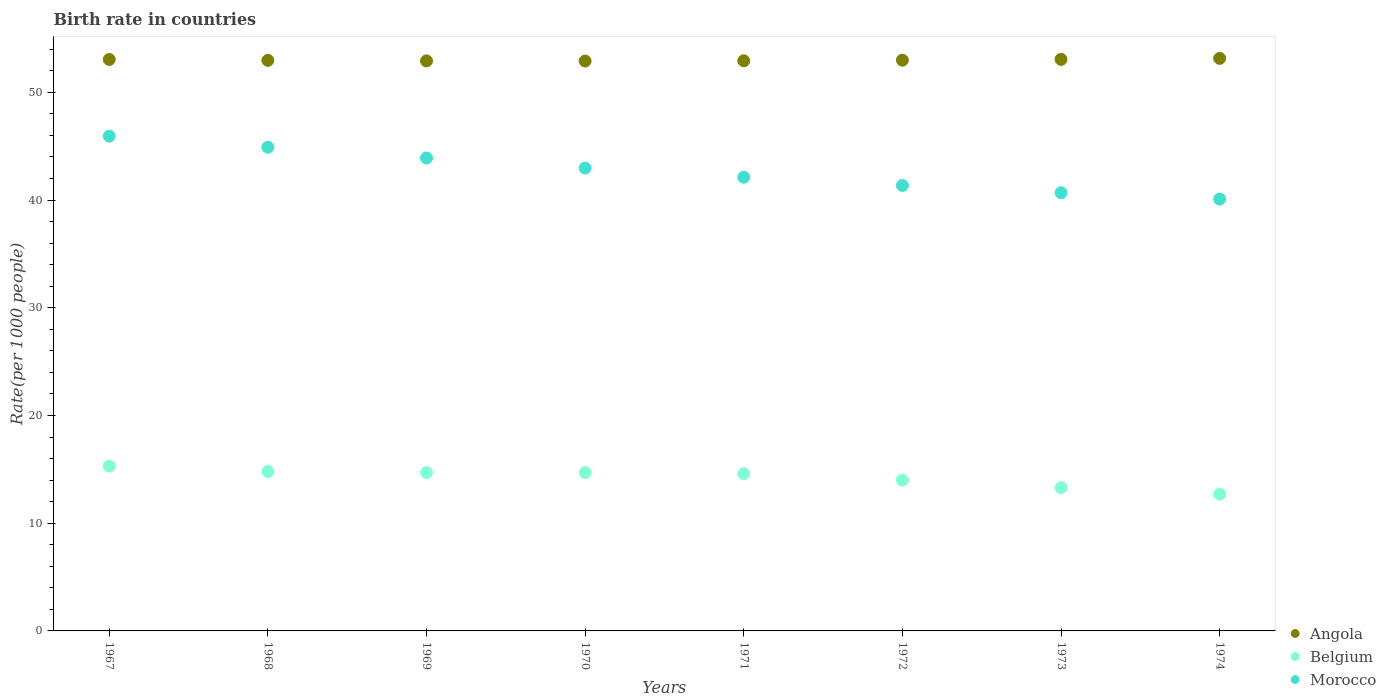How many different coloured dotlines are there?
Your answer should be very brief. 3. Is the number of dotlines equal to the number of legend labels?
Your answer should be very brief. Yes. What is the birth rate in Morocco in 1968?
Your response must be concise. 44.9. In which year was the birth rate in Morocco maximum?
Your response must be concise. 1967. In which year was the birth rate in Belgium minimum?
Give a very brief answer. 1974. What is the total birth rate in Belgium in the graph?
Offer a terse response. 114.1. What is the difference between the birth rate in Angola in 1967 and that in 1972?
Provide a short and direct response. 0.07. What is the difference between the birth rate in Belgium in 1969 and the birth rate in Morocco in 1972?
Your response must be concise. -26.66. What is the average birth rate in Morocco per year?
Keep it short and to the point. 42.74. In the year 1972, what is the difference between the birth rate in Belgium and birth rate in Angola?
Keep it short and to the point. -38.98. In how many years, is the birth rate in Belgium greater than 52?
Offer a terse response. 0. What is the ratio of the birth rate in Belgium in 1968 to that in 1972?
Your answer should be very brief. 1.06. Is the birth rate in Morocco in 1969 less than that in 1973?
Provide a succinct answer. No. Is the difference between the birth rate in Belgium in 1970 and 1971 greater than the difference between the birth rate in Angola in 1970 and 1971?
Give a very brief answer. Yes. What is the difference between the highest and the lowest birth rate in Angola?
Keep it short and to the point. 0.25. Is it the case that in every year, the sum of the birth rate in Belgium and birth rate in Angola  is greater than the birth rate in Morocco?
Keep it short and to the point. Yes. Does the birth rate in Morocco monotonically increase over the years?
Provide a short and direct response. No. Is the birth rate in Morocco strictly less than the birth rate in Belgium over the years?
Your response must be concise. No. How many years are there in the graph?
Ensure brevity in your answer.  8. What is the difference between two consecutive major ticks on the Y-axis?
Offer a terse response. 10. Does the graph contain any zero values?
Your response must be concise. No. How many legend labels are there?
Your answer should be very brief. 3. What is the title of the graph?
Give a very brief answer. Birth rate in countries. What is the label or title of the Y-axis?
Keep it short and to the point. Rate(per 1000 people). What is the Rate(per 1000 people) in Angola in 1967?
Make the answer very short. 53.05. What is the Rate(per 1000 people) of Belgium in 1967?
Your answer should be very brief. 15.3. What is the Rate(per 1000 people) of Morocco in 1967?
Keep it short and to the point. 45.93. What is the Rate(per 1000 people) in Angola in 1968?
Give a very brief answer. 52.97. What is the Rate(per 1000 people) of Belgium in 1968?
Your response must be concise. 14.8. What is the Rate(per 1000 people) in Morocco in 1968?
Ensure brevity in your answer.  44.9. What is the Rate(per 1000 people) in Angola in 1969?
Ensure brevity in your answer.  52.92. What is the Rate(per 1000 people) of Belgium in 1969?
Offer a terse response. 14.7. What is the Rate(per 1000 people) of Morocco in 1969?
Your response must be concise. 43.91. What is the Rate(per 1000 people) of Angola in 1970?
Give a very brief answer. 52.91. What is the Rate(per 1000 people) in Belgium in 1970?
Make the answer very short. 14.7. What is the Rate(per 1000 people) in Morocco in 1970?
Your response must be concise. 42.97. What is the Rate(per 1000 people) in Angola in 1971?
Provide a succinct answer. 52.93. What is the Rate(per 1000 people) of Belgium in 1971?
Give a very brief answer. 14.6. What is the Rate(per 1000 people) in Morocco in 1971?
Make the answer very short. 42.12. What is the Rate(per 1000 people) in Angola in 1972?
Provide a succinct answer. 52.98. What is the Rate(per 1000 people) in Belgium in 1972?
Provide a succinct answer. 14. What is the Rate(per 1000 people) of Morocco in 1972?
Offer a terse response. 41.36. What is the Rate(per 1000 people) of Angola in 1973?
Offer a very short reply. 53.06. What is the Rate(per 1000 people) in Morocco in 1973?
Your response must be concise. 40.68. What is the Rate(per 1000 people) in Angola in 1974?
Your response must be concise. 53.15. What is the Rate(per 1000 people) in Belgium in 1974?
Provide a succinct answer. 12.7. What is the Rate(per 1000 people) in Morocco in 1974?
Give a very brief answer. 40.09. Across all years, what is the maximum Rate(per 1000 people) in Angola?
Provide a succinct answer. 53.15. Across all years, what is the maximum Rate(per 1000 people) in Belgium?
Your answer should be very brief. 15.3. Across all years, what is the maximum Rate(per 1000 people) of Morocco?
Keep it short and to the point. 45.93. Across all years, what is the minimum Rate(per 1000 people) in Angola?
Provide a succinct answer. 52.91. Across all years, what is the minimum Rate(per 1000 people) in Morocco?
Your answer should be very brief. 40.09. What is the total Rate(per 1000 people) in Angola in the graph?
Provide a short and direct response. 423.97. What is the total Rate(per 1000 people) of Belgium in the graph?
Your answer should be compact. 114.1. What is the total Rate(per 1000 people) of Morocco in the graph?
Your answer should be very brief. 341.94. What is the difference between the Rate(per 1000 people) in Angola in 1967 and that in 1968?
Provide a short and direct response. 0.08. What is the difference between the Rate(per 1000 people) of Belgium in 1967 and that in 1968?
Offer a terse response. 0.5. What is the difference between the Rate(per 1000 people) of Angola in 1967 and that in 1969?
Keep it short and to the point. 0.13. What is the difference between the Rate(per 1000 people) in Belgium in 1967 and that in 1969?
Offer a terse response. 0.6. What is the difference between the Rate(per 1000 people) in Morocco in 1967 and that in 1969?
Make the answer very short. 2.02. What is the difference between the Rate(per 1000 people) in Angola in 1967 and that in 1970?
Keep it short and to the point. 0.15. What is the difference between the Rate(per 1000 people) of Belgium in 1967 and that in 1970?
Offer a terse response. 0.6. What is the difference between the Rate(per 1000 people) in Morocco in 1967 and that in 1970?
Provide a short and direct response. 2.96. What is the difference between the Rate(per 1000 people) of Angola in 1967 and that in 1971?
Give a very brief answer. 0.12. What is the difference between the Rate(per 1000 people) in Morocco in 1967 and that in 1971?
Make the answer very short. 3.81. What is the difference between the Rate(per 1000 people) in Angola in 1967 and that in 1972?
Your answer should be very brief. 0.07. What is the difference between the Rate(per 1000 people) of Belgium in 1967 and that in 1972?
Offer a terse response. 1.3. What is the difference between the Rate(per 1000 people) in Morocco in 1967 and that in 1972?
Keep it short and to the point. 4.57. What is the difference between the Rate(per 1000 people) of Angola in 1967 and that in 1973?
Give a very brief answer. -0.01. What is the difference between the Rate(per 1000 people) in Morocco in 1967 and that in 1973?
Make the answer very short. 5.25. What is the difference between the Rate(per 1000 people) of Angola in 1967 and that in 1974?
Your answer should be very brief. -0.1. What is the difference between the Rate(per 1000 people) of Belgium in 1967 and that in 1974?
Ensure brevity in your answer.  2.6. What is the difference between the Rate(per 1000 people) of Morocco in 1967 and that in 1974?
Keep it short and to the point. 5.84. What is the difference between the Rate(per 1000 people) in Angola in 1968 and that in 1969?
Offer a very short reply. 0.05. What is the difference between the Rate(per 1000 people) of Angola in 1968 and that in 1970?
Your answer should be very brief. 0.06. What is the difference between the Rate(per 1000 people) of Morocco in 1968 and that in 1970?
Your answer should be very brief. 1.93. What is the difference between the Rate(per 1000 people) of Morocco in 1968 and that in 1971?
Provide a short and direct response. 2.78. What is the difference between the Rate(per 1000 people) in Angola in 1968 and that in 1972?
Your response must be concise. -0.01. What is the difference between the Rate(per 1000 people) of Belgium in 1968 and that in 1972?
Your response must be concise. 0.8. What is the difference between the Rate(per 1000 people) of Morocco in 1968 and that in 1972?
Your answer should be very brief. 3.55. What is the difference between the Rate(per 1000 people) in Angola in 1968 and that in 1973?
Your answer should be compact. -0.09. What is the difference between the Rate(per 1000 people) in Belgium in 1968 and that in 1973?
Offer a very short reply. 1.5. What is the difference between the Rate(per 1000 people) in Morocco in 1968 and that in 1973?
Give a very brief answer. 4.22. What is the difference between the Rate(per 1000 people) of Angola in 1968 and that in 1974?
Your answer should be compact. -0.18. What is the difference between the Rate(per 1000 people) of Belgium in 1968 and that in 1974?
Offer a terse response. 2.1. What is the difference between the Rate(per 1000 people) of Morocco in 1968 and that in 1974?
Offer a very short reply. 4.81. What is the difference between the Rate(per 1000 people) in Angola in 1969 and that in 1970?
Provide a succinct answer. 0.01. What is the difference between the Rate(per 1000 people) of Belgium in 1969 and that in 1970?
Ensure brevity in your answer.  0. What is the difference between the Rate(per 1000 people) of Morocco in 1969 and that in 1970?
Make the answer very short. 0.94. What is the difference between the Rate(per 1000 people) of Angola in 1969 and that in 1971?
Ensure brevity in your answer.  -0.01. What is the difference between the Rate(per 1000 people) of Morocco in 1969 and that in 1971?
Keep it short and to the point. 1.79. What is the difference between the Rate(per 1000 people) of Angola in 1969 and that in 1972?
Provide a short and direct response. -0.06. What is the difference between the Rate(per 1000 people) in Morocco in 1969 and that in 1972?
Your answer should be compact. 2.55. What is the difference between the Rate(per 1000 people) in Angola in 1969 and that in 1973?
Your answer should be very brief. -0.14. What is the difference between the Rate(per 1000 people) of Morocco in 1969 and that in 1973?
Your response must be concise. 3.23. What is the difference between the Rate(per 1000 people) of Angola in 1969 and that in 1974?
Give a very brief answer. -0.23. What is the difference between the Rate(per 1000 people) of Belgium in 1969 and that in 1974?
Your answer should be compact. 2. What is the difference between the Rate(per 1000 people) of Morocco in 1969 and that in 1974?
Your answer should be compact. 3.82. What is the difference between the Rate(per 1000 people) in Angola in 1970 and that in 1971?
Ensure brevity in your answer.  -0.02. What is the difference between the Rate(per 1000 people) in Belgium in 1970 and that in 1971?
Your response must be concise. 0.1. What is the difference between the Rate(per 1000 people) in Angola in 1970 and that in 1972?
Provide a short and direct response. -0.08. What is the difference between the Rate(per 1000 people) in Belgium in 1970 and that in 1972?
Offer a terse response. 0.7. What is the difference between the Rate(per 1000 people) of Morocco in 1970 and that in 1972?
Your response must be concise. 1.61. What is the difference between the Rate(per 1000 people) of Angola in 1970 and that in 1973?
Your answer should be very brief. -0.16. What is the difference between the Rate(per 1000 people) of Belgium in 1970 and that in 1973?
Ensure brevity in your answer.  1.4. What is the difference between the Rate(per 1000 people) in Morocco in 1970 and that in 1973?
Your answer should be very brief. 2.29. What is the difference between the Rate(per 1000 people) of Angola in 1970 and that in 1974?
Provide a succinct answer. -0.25. What is the difference between the Rate(per 1000 people) in Belgium in 1970 and that in 1974?
Provide a succinct answer. 2. What is the difference between the Rate(per 1000 people) in Morocco in 1970 and that in 1974?
Provide a short and direct response. 2.88. What is the difference between the Rate(per 1000 people) of Angola in 1971 and that in 1972?
Your response must be concise. -0.06. What is the difference between the Rate(per 1000 people) of Morocco in 1971 and that in 1972?
Your response must be concise. 0.76. What is the difference between the Rate(per 1000 people) in Angola in 1971 and that in 1973?
Provide a short and direct response. -0.13. What is the difference between the Rate(per 1000 people) in Belgium in 1971 and that in 1973?
Provide a short and direct response. 1.3. What is the difference between the Rate(per 1000 people) in Morocco in 1971 and that in 1973?
Provide a succinct answer. 1.44. What is the difference between the Rate(per 1000 people) of Angola in 1971 and that in 1974?
Offer a very short reply. -0.23. What is the difference between the Rate(per 1000 people) in Belgium in 1971 and that in 1974?
Your answer should be compact. 1.9. What is the difference between the Rate(per 1000 people) of Morocco in 1971 and that in 1974?
Provide a succinct answer. 2.03. What is the difference between the Rate(per 1000 people) in Angola in 1972 and that in 1973?
Keep it short and to the point. -0.08. What is the difference between the Rate(per 1000 people) in Morocco in 1972 and that in 1973?
Offer a terse response. 0.68. What is the difference between the Rate(per 1000 people) in Angola in 1972 and that in 1974?
Make the answer very short. -0.17. What is the difference between the Rate(per 1000 people) in Morocco in 1972 and that in 1974?
Your response must be concise. 1.27. What is the difference between the Rate(per 1000 people) in Angola in 1973 and that in 1974?
Your answer should be very brief. -0.09. What is the difference between the Rate(per 1000 people) of Morocco in 1973 and that in 1974?
Offer a terse response. 0.59. What is the difference between the Rate(per 1000 people) in Angola in 1967 and the Rate(per 1000 people) in Belgium in 1968?
Provide a short and direct response. 38.25. What is the difference between the Rate(per 1000 people) of Angola in 1967 and the Rate(per 1000 people) of Morocco in 1968?
Your answer should be very brief. 8.15. What is the difference between the Rate(per 1000 people) of Belgium in 1967 and the Rate(per 1000 people) of Morocco in 1968?
Ensure brevity in your answer.  -29.6. What is the difference between the Rate(per 1000 people) of Angola in 1967 and the Rate(per 1000 people) of Belgium in 1969?
Your response must be concise. 38.35. What is the difference between the Rate(per 1000 people) in Angola in 1967 and the Rate(per 1000 people) in Morocco in 1969?
Give a very brief answer. 9.15. What is the difference between the Rate(per 1000 people) of Belgium in 1967 and the Rate(per 1000 people) of Morocco in 1969?
Your response must be concise. -28.61. What is the difference between the Rate(per 1000 people) of Angola in 1967 and the Rate(per 1000 people) of Belgium in 1970?
Your answer should be compact. 38.35. What is the difference between the Rate(per 1000 people) of Angola in 1967 and the Rate(per 1000 people) of Morocco in 1970?
Your response must be concise. 10.08. What is the difference between the Rate(per 1000 people) in Belgium in 1967 and the Rate(per 1000 people) in Morocco in 1970?
Your response must be concise. -27.67. What is the difference between the Rate(per 1000 people) in Angola in 1967 and the Rate(per 1000 people) in Belgium in 1971?
Provide a short and direct response. 38.45. What is the difference between the Rate(per 1000 people) of Angola in 1967 and the Rate(per 1000 people) of Morocco in 1971?
Your answer should be very brief. 10.93. What is the difference between the Rate(per 1000 people) of Belgium in 1967 and the Rate(per 1000 people) of Morocco in 1971?
Ensure brevity in your answer.  -26.82. What is the difference between the Rate(per 1000 people) of Angola in 1967 and the Rate(per 1000 people) of Belgium in 1972?
Make the answer very short. 39.05. What is the difference between the Rate(per 1000 people) in Angola in 1967 and the Rate(per 1000 people) in Morocco in 1972?
Keep it short and to the point. 11.7. What is the difference between the Rate(per 1000 people) of Belgium in 1967 and the Rate(per 1000 people) of Morocco in 1972?
Your answer should be very brief. -26.06. What is the difference between the Rate(per 1000 people) of Angola in 1967 and the Rate(per 1000 people) of Belgium in 1973?
Your answer should be very brief. 39.75. What is the difference between the Rate(per 1000 people) of Angola in 1967 and the Rate(per 1000 people) of Morocco in 1973?
Make the answer very short. 12.37. What is the difference between the Rate(per 1000 people) of Belgium in 1967 and the Rate(per 1000 people) of Morocco in 1973?
Provide a short and direct response. -25.38. What is the difference between the Rate(per 1000 people) of Angola in 1967 and the Rate(per 1000 people) of Belgium in 1974?
Offer a terse response. 40.35. What is the difference between the Rate(per 1000 people) of Angola in 1967 and the Rate(per 1000 people) of Morocco in 1974?
Make the answer very short. 12.96. What is the difference between the Rate(per 1000 people) of Belgium in 1967 and the Rate(per 1000 people) of Morocco in 1974?
Offer a terse response. -24.79. What is the difference between the Rate(per 1000 people) in Angola in 1968 and the Rate(per 1000 people) in Belgium in 1969?
Your response must be concise. 38.27. What is the difference between the Rate(per 1000 people) of Angola in 1968 and the Rate(per 1000 people) of Morocco in 1969?
Provide a succinct answer. 9.06. What is the difference between the Rate(per 1000 people) of Belgium in 1968 and the Rate(per 1000 people) of Morocco in 1969?
Your answer should be compact. -29.11. What is the difference between the Rate(per 1000 people) in Angola in 1968 and the Rate(per 1000 people) in Belgium in 1970?
Offer a terse response. 38.27. What is the difference between the Rate(per 1000 people) of Angola in 1968 and the Rate(per 1000 people) of Morocco in 1970?
Offer a very short reply. 10. What is the difference between the Rate(per 1000 people) of Belgium in 1968 and the Rate(per 1000 people) of Morocco in 1970?
Ensure brevity in your answer.  -28.17. What is the difference between the Rate(per 1000 people) of Angola in 1968 and the Rate(per 1000 people) of Belgium in 1971?
Ensure brevity in your answer.  38.37. What is the difference between the Rate(per 1000 people) in Angola in 1968 and the Rate(per 1000 people) in Morocco in 1971?
Provide a short and direct response. 10.85. What is the difference between the Rate(per 1000 people) of Belgium in 1968 and the Rate(per 1000 people) of Morocco in 1971?
Keep it short and to the point. -27.32. What is the difference between the Rate(per 1000 people) in Angola in 1968 and the Rate(per 1000 people) in Belgium in 1972?
Your answer should be compact. 38.97. What is the difference between the Rate(per 1000 people) of Angola in 1968 and the Rate(per 1000 people) of Morocco in 1972?
Provide a succinct answer. 11.61. What is the difference between the Rate(per 1000 people) of Belgium in 1968 and the Rate(per 1000 people) of Morocco in 1972?
Make the answer very short. -26.56. What is the difference between the Rate(per 1000 people) of Angola in 1968 and the Rate(per 1000 people) of Belgium in 1973?
Offer a very short reply. 39.67. What is the difference between the Rate(per 1000 people) of Angola in 1968 and the Rate(per 1000 people) of Morocco in 1973?
Your answer should be compact. 12.29. What is the difference between the Rate(per 1000 people) in Belgium in 1968 and the Rate(per 1000 people) in Morocco in 1973?
Offer a terse response. -25.88. What is the difference between the Rate(per 1000 people) in Angola in 1968 and the Rate(per 1000 people) in Belgium in 1974?
Make the answer very short. 40.27. What is the difference between the Rate(per 1000 people) in Angola in 1968 and the Rate(per 1000 people) in Morocco in 1974?
Your answer should be very brief. 12.88. What is the difference between the Rate(per 1000 people) in Belgium in 1968 and the Rate(per 1000 people) in Morocco in 1974?
Offer a very short reply. -25.29. What is the difference between the Rate(per 1000 people) of Angola in 1969 and the Rate(per 1000 people) of Belgium in 1970?
Offer a terse response. 38.22. What is the difference between the Rate(per 1000 people) of Angola in 1969 and the Rate(per 1000 people) of Morocco in 1970?
Provide a succinct answer. 9.95. What is the difference between the Rate(per 1000 people) in Belgium in 1969 and the Rate(per 1000 people) in Morocco in 1970?
Keep it short and to the point. -28.27. What is the difference between the Rate(per 1000 people) in Angola in 1969 and the Rate(per 1000 people) in Belgium in 1971?
Provide a short and direct response. 38.32. What is the difference between the Rate(per 1000 people) in Angola in 1969 and the Rate(per 1000 people) in Morocco in 1971?
Provide a short and direct response. 10.8. What is the difference between the Rate(per 1000 people) in Belgium in 1969 and the Rate(per 1000 people) in Morocco in 1971?
Ensure brevity in your answer.  -27.42. What is the difference between the Rate(per 1000 people) in Angola in 1969 and the Rate(per 1000 people) in Belgium in 1972?
Offer a terse response. 38.92. What is the difference between the Rate(per 1000 people) in Angola in 1969 and the Rate(per 1000 people) in Morocco in 1972?
Offer a very short reply. 11.56. What is the difference between the Rate(per 1000 people) of Belgium in 1969 and the Rate(per 1000 people) of Morocco in 1972?
Ensure brevity in your answer.  -26.66. What is the difference between the Rate(per 1000 people) in Angola in 1969 and the Rate(per 1000 people) in Belgium in 1973?
Keep it short and to the point. 39.62. What is the difference between the Rate(per 1000 people) of Angola in 1969 and the Rate(per 1000 people) of Morocco in 1973?
Your answer should be very brief. 12.24. What is the difference between the Rate(per 1000 people) of Belgium in 1969 and the Rate(per 1000 people) of Morocco in 1973?
Make the answer very short. -25.98. What is the difference between the Rate(per 1000 people) of Angola in 1969 and the Rate(per 1000 people) of Belgium in 1974?
Your answer should be very brief. 40.22. What is the difference between the Rate(per 1000 people) in Angola in 1969 and the Rate(per 1000 people) in Morocco in 1974?
Your answer should be very brief. 12.83. What is the difference between the Rate(per 1000 people) of Belgium in 1969 and the Rate(per 1000 people) of Morocco in 1974?
Make the answer very short. -25.39. What is the difference between the Rate(per 1000 people) of Angola in 1970 and the Rate(per 1000 people) of Belgium in 1971?
Make the answer very short. 38.3. What is the difference between the Rate(per 1000 people) of Angola in 1970 and the Rate(per 1000 people) of Morocco in 1971?
Make the answer very short. 10.79. What is the difference between the Rate(per 1000 people) of Belgium in 1970 and the Rate(per 1000 people) of Morocco in 1971?
Provide a succinct answer. -27.42. What is the difference between the Rate(per 1000 people) in Angola in 1970 and the Rate(per 1000 people) in Belgium in 1972?
Make the answer very short. 38.91. What is the difference between the Rate(per 1000 people) in Angola in 1970 and the Rate(per 1000 people) in Morocco in 1972?
Offer a terse response. 11.55. What is the difference between the Rate(per 1000 people) of Belgium in 1970 and the Rate(per 1000 people) of Morocco in 1972?
Keep it short and to the point. -26.66. What is the difference between the Rate(per 1000 people) in Angola in 1970 and the Rate(per 1000 people) in Belgium in 1973?
Your answer should be very brief. 39.6. What is the difference between the Rate(per 1000 people) of Angola in 1970 and the Rate(per 1000 people) of Morocco in 1973?
Your response must be concise. 12.23. What is the difference between the Rate(per 1000 people) of Belgium in 1970 and the Rate(per 1000 people) of Morocco in 1973?
Offer a very short reply. -25.98. What is the difference between the Rate(per 1000 people) in Angola in 1970 and the Rate(per 1000 people) in Belgium in 1974?
Keep it short and to the point. 40.2. What is the difference between the Rate(per 1000 people) of Angola in 1970 and the Rate(per 1000 people) of Morocco in 1974?
Your answer should be compact. 12.82. What is the difference between the Rate(per 1000 people) of Belgium in 1970 and the Rate(per 1000 people) of Morocco in 1974?
Make the answer very short. -25.39. What is the difference between the Rate(per 1000 people) of Angola in 1971 and the Rate(per 1000 people) of Belgium in 1972?
Give a very brief answer. 38.93. What is the difference between the Rate(per 1000 people) of Angola in 1971 and the Rate(per 1000 people) of Morocco in 1972?
Offer a very short reply. 11.57. What is the difference between the Rate(per 1000 people) of Belgium in 1971 and the Rate(per 1000 people) of Morocco in 1972?
Provide a succinct answer. -26.76. What is the difference between the Rate(per 1000 people) in Angola in 1971 and the Rate(per 1000 people) in Belgium in 1973?
Your answer should be very brief. 39.63. What is the difference between the Rate(per 1000 people) of Angola in 1971 and the Rate(per 1000 people) of Morocco in 1973?
Keep it short and to the point. 12.25. What is the difference between the Rate(per 1000 people) in Belgium in 1971 and the Rate(per 1000 people) in Morocco in 1973?
Offer a very short reply. -26.08. What is the difference between the Rate(per 1000 people) of Angola in 1971 and the Rate(per 1000 people) of Belgium in 1974?
Ensure brevity in your answer.  40.23. What is the difference between the Rate(per 1000 people) in Angola in 1971 and the Rate(per 1000 people) in Morocco in 1974?
Keep it short and to the point. 12.84. What is the difference between the Rate(per 1000 people) in Belgium in 1971 and the Rate(per 1000 people) in Morocco in 1974?
Provide a short and direct response. -25.49. What is the difference between the Rate(per 1000 people) in Angola in 1972 and the Rate(per 1000 people) in Belgium in 1973?
Offer a terse response. 39.68. What is the difference between the Rate(per 1000 people) in Angola in 1972 and the Rate(per 1000 people) in Morocco in 1973?
Make the answer very short. 12.3. What is the difference between the Rate(per 1000 people) of Belgium in 1972 and the Rate(per 1000 people) of Morocco in 1973?
Your response must be concise. -26.68. What is the difference between the Rate(per 1000 people) of Angola in 1972 and the Rate(per 1000 people) of Belgium in 1974?
Offer a very short reply. 40.28. What is the difference between the Rate(per 1000 people) in Angola in 1972 and the Rate(per 1000 people) in Morocco in 1974?
Make the answer very short. 12.89. What is the difference between the Rate(per 1000 people) in Belgium in 1972 and the Rate(per 1000 people) in Morocco in 1974?
Your answer should be compact. -26.09. What is the difference between the Rate(per 1000 people) of Angola in 1973 and the Rate(per 1000 people) of Belgium in 1974?
Make the answer very short. 40.36. What is the difference between the Rate(per 1000 people) of Angola in 1973 and the Rate(per 1000 people) of Morocco in 1974?
Keep it short and to the point. 12.97. What is the difference between the Rate(per 1000 people) in Belgium in 1973 and the Rate(per 1000 people) in Morocco in 1974?
Provide a succinct answer. -26.79. What is the average Rate(per 1000 people) in Angola per year?
Make the answer very short. 53. What is the average Rate(per 1000 people) in Belgium per year?
Make the answer very short. 14.26. What is the average Rate(per 1000 people) of Morocco per year?
Your answer should be very brief. 42.74. In the year 1967, what is the difference between the Rate(per 1000 people) in Angola and Rate(per 1000 people) in Belgium?
Your answer should be compact. 37.75. In the year 1967, what is the difference between the Rate(per 1000 people) in Angola and Rate(per 1000 people) in Morocco?
Your response must be concise. 7.12. In the year 1967, what is the difference between the Rate(per 1000 people) of Belgium and Rate(per 1000 people) of Morocco?
Ensure brevity in your answer.  -30.63. In the year 1968, what is the difference between the Rate(per 1000 people) of Angola and Rate(per 1000 people) of Belgium?
Provide a succinct answer. 38.17. In the year 1968, what is the difference between the Rate(per 1000 people) of Angola and Rate(per 1000 people) of Morocco?
Offer a terse response. 8.07. In the year 1968, what is the difference between the Rate(per 1000 people) of Belgium and Rate(per 1000 people) of Morocco?
Offer a very short reply. -30.1. In the year 1969, what is the difference between the Rate(per 1000 people) in Angola and Rate(per 1000 people) in Belgium?
Provide a succinct answer. 38.22. In the year 1969, what is the difference between the Rate(per 1000 people) of Angola and Rate(per 1000 people) of Morocco?
Provide a short and direct response. 9.01. In the year 1969, what is the difference between the Rate(per 1000 people) of Belgium and Rate(per 1000 people) of Morocco?
Keep it short and to the point. -29.2. In the year 1970, what is the difference between the Rate(per 1000 people) of Angola and Rate(per 1000 people) of Belgium?
Ensure brevity in your answer.  38.2. In the year 1970, what is the difference between the Rate(per 1000 people) of Angola and Rate(per 1000 people) of Morocco?
Your answer should be very brief. 9.94. In the year 1970, what is the difference between the Rate(per 1000 people) in Belgium and Rate(per 1000 people) in Morocco?
Your answer should be very brief. -28.27. In the year 1971, what is the difference between the Rate(per 1000 people) in Angola and Rate(per 1000 people) in Belgium?
Provide a short and direct response. 38.33. In the year 1971, what is the difference between the Rate(per 1000 people) in Angola and Rate(per 1000 people) in Morocco?
Offer a very short reply. 10.81. In the year 1971, what is the difference between the Rate(per 1000 people) in Belgium and Rate(per 1000 people) in Morocco?
Keep it short and to the point. -27.52. In the year 1972, what is the difference between the Rate(per 1000 people) in Angola and Rate(per 1000 people) in Belgium?
Your response must be concise. 38.98. In the year 1972, what is the difference between the Rate(per 1000 people) of Angola and Rate(per 1000 people) of Morocco?
Keep it short and to the point. 11.63. In the year 1972, what is the difference between the Rate(per 1000 people) in Belgium and Rate(per 1000 people) in Morocco?
Give a very brief answer. -27.36. In the year 1973, what is the difference between the Rate(per 1000 people) in Angola and Rate(per 1000 people) in Belgium?
Make the answer very short. 39.76. In the year 1973, what is the difference between the Rate(per 1000 people) in Angola and Rate(per 1000 people) in Morocco?
Ensure brevity in your answer.  12.38. In the year 1973, what is the difference between the Rate(per 1000 people) of Belgium and Rate(per 1000 people) of Morocco?
Your answer should be very brief. -27.38. In the year 1974, what is the difference between the Rate(per 1000 people) in Angola and Rate(per 1000 people) in Belgium?
Provide a short and direct response. 40.45. In the year 1974, what is the difference between the Rate(per 1000 people) of Angola and Rate(per 1000 people) of Morocco?
Your answer should be compact. 13.06. In the year 1974, what is the difference between the Rate(per 1000 people) in Belgium and Rate(per 1000 people) in Morocco?
Provide a succinct answer. -27.39. What is the ratio of the Rate(per 1000 people) in Belgium in 1967 to that in 1968?
Keep it short and to the point. 1.03. What is the ratio of the Rate(per 1000 people) in Morocco in 1967 to that in 1968?
Provide a short and direct response. 1.02. What is the ratio of the Rate(per 1000 people) in Angola in 1967 to that in 1969?
Ensure brevity in your answer.  1. What is the ratio of the Rate(per 1000 people) in Belgium in 1967 to that in 1969?
Your answer should be compact. 1.04. What is the ratio of the Rate(per 1000 people) of Morocco in 1967 to that in 1969?
Keep it short and to the point. 1.05. What is the ratio of the Rate(per 1000 people) of Angola in 1967 to that in 1970?
Your answer should be compact. 1. What is the ratio of the Rate(per 1000 people) of Belgium in 1967 to that in 1970?
Provide a succinct answer. 1.04. What is the ratio of the Rate(per 1000 people) of Morocco in 1967 to that in 1970?
Keep it short and to the point. 1.07. What is the ratio of the Rate(per 1000 people) in Angola in 1967 to that in 1971?
Ensure brevity in your answer.  1. What is the ratio of the Rate(per 1000 people) of Belgium in 1967 to that in 1971?
Your answer should be very brief. 1.05. What is the ratio of the Rate(per 1000 people) in Morocco in 1967 to that in 1971?
Offer a very short reply. 1.09. What is the ratio of the Rate(per 1000 people) of Angola in 1967 to that in 1972?
Keep it short and to the point. 1. What is the ratio of the Rate(per 1000 people) in Belgium in 1967 to that in 1972?
Give a very brief answer. 1.09. What is the ratio of the Rate(per 1000 people) of Morocco in 1967 to that in 1972?
Your answer should be very brief. 1.11. What is the ratio of the Rate(per 1000 people) in Angola in 1967 to that in 1973?
Keep it short and to the point. 1. What is the ratio of the Rate(per 1000 people) in Belgium in 1967 to that in 1973?
Offer a terse response. 1.15. What is the ratio of the Rate(per 1000 people) of Morocco in 1967 to that in 1973?
Ensure brevity in your answer.  1.13. What is the ratio of the Rate(per 1000 people) of Angola in 1967 to that in 1974?
Your response must be concise. 1. What is the ratio of the Rate(per 1000 people) in Belgium in 1967 to that in 1974?
Ensure brevity in your answer.  1.2. What is the ratio of the Rate(per 1000 people) of Morocco in 1967 to that in 1974?
Your response must be concise. 1.15. What is the ratio of the Rate(per 1000 people) in Belgium in 1968 to that in 1969?
Provide a short and direct response. 1.01. What is the ratio of the Rate(per 1000 people) of Morocco in 1968 to that in 1969?
Your answer should be compact. 1.02. What is the ratio of the Rate(per 1000 people) of Angola in 1968 to that in 1970?
Keep it short and to the point. 1. What is the ratio of the Rate(per 1000 people) of Belgium in 1968 to that in 1970?
Make the answer very short. 1.01. What is the ratio of the Rate(per 1000 people) of Morocco in 1968 to that in 1970?
Provide a succinct answer. 1.04. What is the ratio of the Rate(per 1000 people) of Belgium in 1968 to that in 1971?
Make the answer very short. 1.01. What is the ratio of the Rate(per 1000 people) of Morocco in 1968 to that in 1971?
Provide a short and direct response. 1.07. What is the ratio of the Rate(per 1000 people) of Angola in 1968 to that in 1972?
Your answer should be very brief. 1. What is the ratio of the Rate(per 1000 people) in Belgium in 1968 to that in 1972?
Ensure brevity in your answer.  1.06. What is the ratio of the Rate(per 1000 people) of Morocco in 1968 to that in 1972?
Ensure brevity in your answer.  1.09. What is the ratio of the Rate(per 1000 people) of Belgium in 1968 to that in 1973?
Your answer should be very brief. 1.11. What is the ratio of the Rate(per 1000 people) in Morocco in 1968 to that in 1973?
Offer a very short reply. 1.1. What is the ratio of the Rate(per 1000 people) of Angola in 1968 to that in 1974?
Ensure brevity in your answer.  1. What is the ratio of the Rate(per 1000 people) of Belgium in 1968 to that in 1974?
Make the answer very short. 1.17. What is the ratio of the Rate(per 1000 people) of Morocco in 1968 to that in 1974?
Provide a short and direct response. 1.12. What is the ratio of the Rate(per 1000 people) in Angola in 1969 to that in 1970?
Keep it short and to the point. 1. What is the ratio of the Rate(per 1000 people) in Belgium in 1969 to that in 1970?
Offer a terse response. 1. What is the ratio of the Rate(per 1000 people) in Morocco in 1969 to that in 1970?
Provide a succinct answer. 1.02. What is the ratio of the Rate(per 1000 people) in Belgium in 1969 to that in 1971?
Your answer should be very brief. 1.01. What is the ratio of the Rate(per 1000 people) in Morocco in 1969 to that in 1971?
Provide a short and direct response. 1.04. What is the ratio of the Rate(per 1000 people) of Belgium in 1969 to that in 1972?
Make the answer very short. 1.05. What is the ratio of the Rate(per 1000 people) of Morocco in 1969 to that in 1972?
Give a very brief answer. 1.06. What is the ratio of the Rate(per 1000 people) of Angola in 1969 to that in 1973?
Give a very brief answer. 1. What is the ratio of the Rate(per 1000 people) of Belgium in 1969 to that in 1973?
Ensure brevity in your answer.  1.11. What is the ratio of the Rate(per 1000 people) in Morocco in 1969 to that in 1973?
Give a very brief answer. 1.08. What is the ratio of the Rate(per 1000 people) in Belgium in 1969 to that in 1974?
Your answer should be compact. 1.16. What is the ratio of the Rate(per 1000 people) of Morocco in 1969 to that in 1974?
Give a very brief answer. 1.1. What is the ratio of the Rate(per 1000 people) of Angola in 1970 to that in 1971?
Give a very brief answer. 1. What is the ratio of the Rate(per 1000 people) of Belgium in 1970 to that in 1971?
Make the answer very short. 1.01. What is the ratio of the Rate(per 1000 people) of Morocco in 1970 to that in 1971?
Offer a very short reply. 1.02. What is the ratio of the Rate(per 1000 people) of Morocco in 1970 to that in 1972?
Provide a short and direct response. 1.04. What is the ratio of the Rate(per 1000 people) in Angola in 1970 to that in 1973?
Ensure brevity in your answer.  1. What is the ratio of the Rate(per 1000 people) of Belgium in 1970 to that in 1973?
Your answer should be very brief. 1.11. What is the ratio of the Rate(per 1000 people) of Morocco in 1970 to that in 1973?
Provide a short and direct response. 1.06. What is the ratio of the Rate(per 1000 people) of Belgium in 1970 to that in 1974?
Provide a succinct answer. 1.16. What is the ratio of the Rate(per 1000 people) in Morocco in 1970 to that in 1974?
Offer a terse response. 1.07. What is the ratio of the Rate(per 1000 people) of Belgium in 1971 to that in 1972?
Offer a very short reply. 1.04. What is the ratio of the Rate(per 1000 people) in Morocco in 1971 to that in 1972?
Your answer should be very brief. 1.02. What is the ratio of the Rate(per 1000 people) in Belgium in 1971 to that in 1973?
Your response must be concise. 1.1. What is the ratio of the Rate(per 1000 people) of Morocco in 1971 to that in 1973?
Provide a succinct answer. 1.04. What is the ratio of the Rate(per 1000 people) in Angola in 1971 to that in 1974?
Make the answer very short. 1. What is the ratio of the Rate(per 1000 people) of Belgium in 1971 to that in 1974?
Make the answer very short. 1.15. What is the ratio of the Rate(per 1000 people) in Morocco in 1971 to that in 1974?
Give a very brief answer. 1.05. What is the ratio of the Rate(per 1000 people) in Angola in 1972 to that in 1973?
Give a very brief answer. 1. What is the ratio of the Rate(per 1000 people) of Belgium in 1972 to that in 1973?
Offer a very short reply. 1.05. What is the ratio of the Rate(per 1000 people) in Morocco in 1972 to that in 1973?
Provide a short and direct response. 1.02. What is the ratio of the Rate(per 1000 people) in Angola in 1972 to that in 1974?
Give a very brief answer. 1. What is the ratio of the Rate(per 1000 people) of Belgium in 1972 to that in 1974?
Give a very brief answer. 1.1. What is the ratio of the Rate(per 1000 people) of Morocco in 1972 to that in 1974?
Give a very brief answer. 1.03. What is the ratio of the Rate(per 1000 people) in Angola in 1973 to that in 1974?
Offer a very short reply. 1. What is the ratio of the Rate(per 1000 people) of Belgium in 1973 to that in 1974?
Provide a succinct answer. 1.05. What is the ratio of the Rate(per 1000 people) in Morocco in 1973 to that in 1974?
Give a very brief answer. 1.01. What is the difference between the highest and the second highest Rate(per 1000 people) of Angola?
Provide a short and direct response. 0.09. What is the difference between the highest and the second highest Rate(per 1000 people) of Belgium?
Make the answer very short. 0.5. What is the difference between the highest and the lowest Rate(per 1000 people) of Angola?
Keep it short and to the point. 0.25. What is the difference between the highest and the lowest Rate(per 1000 people) of Morocco?
Offer a terse response. 5.84. 